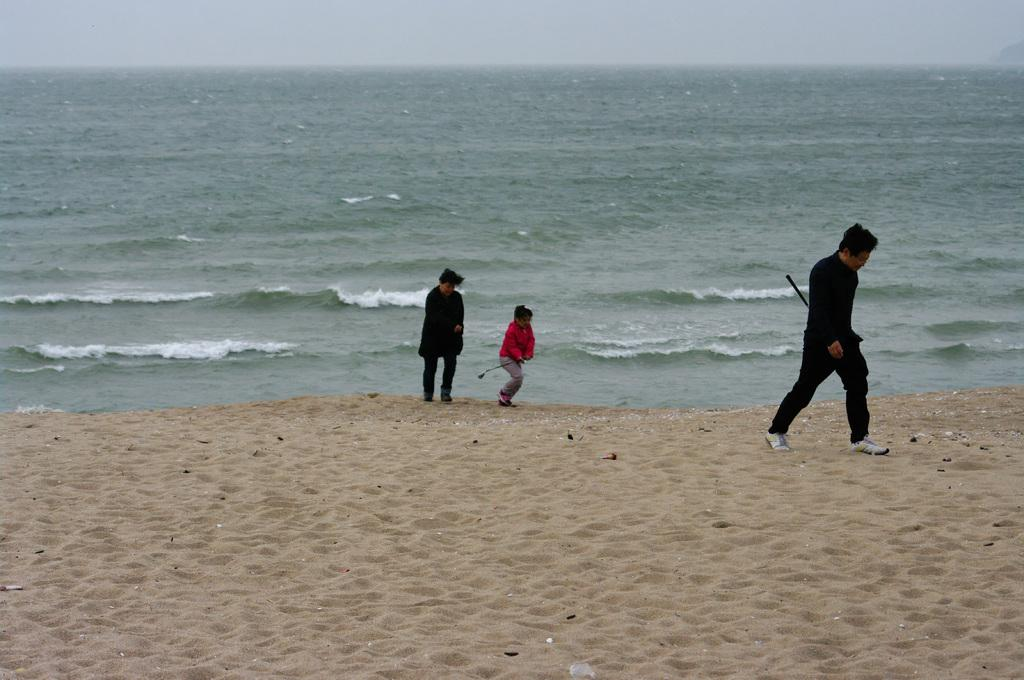How many people are in the image? There are three persons in the image. What are the persons doing in the image? The persons are walking. What type of terrain is visible at the bottom of the image? There is sand at the bottom of the image. What type of location is depicted in the background of the image? There is a beach in the background of the image. What is visible at the top of the image? The sky is visible at the top of the image. What shape is the rabbit in the image? There is no rabbit present in the image. What answer can be found in the image? The image does not contain any questions or answers; it is a scene of three people walking on a beach. 